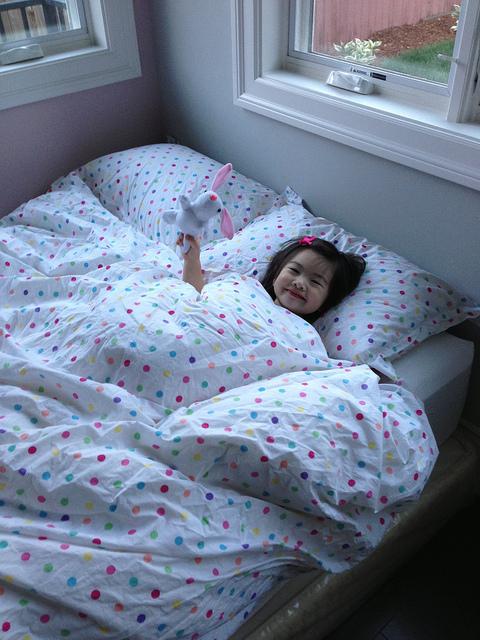What pattern is the bedding?
Answer briefly. Polka dot. What is the little girl holding?
Keep it brief. Bunny. Is the little girl making her bed?
Keep it brief. No. 